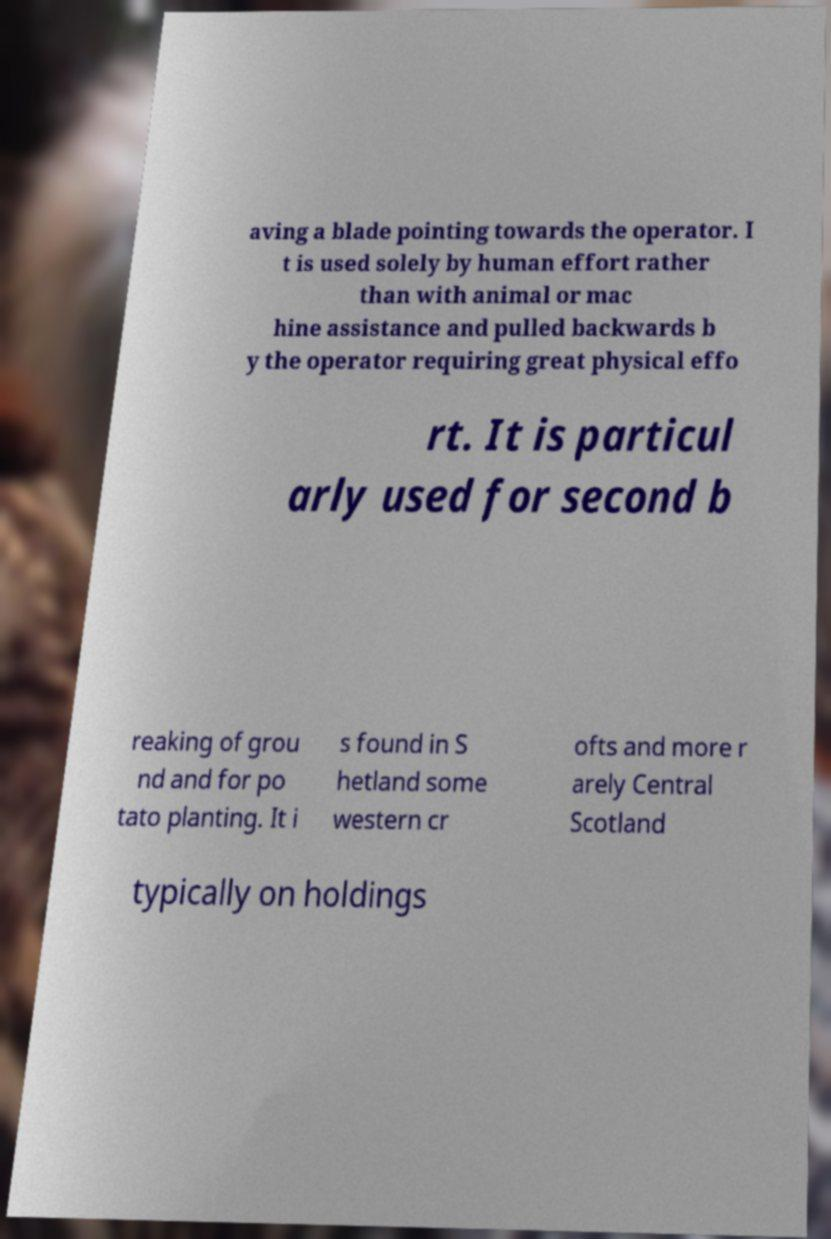Can you read and provide the text displayed in the image?This photo seems to have some interesting text. Can you extract and type it out for me? aving a blade pointing towards the operator. I t is used solely by human effort rather than with animal or mac hine assistance and pulled backwards b y the operator requiring great physical effo rt. It is particul arly used for second b reaking of grou nd and for po tato planting. It i s found in S hetland some western cr ofts and more r arely Central Scotland typically on holdings 